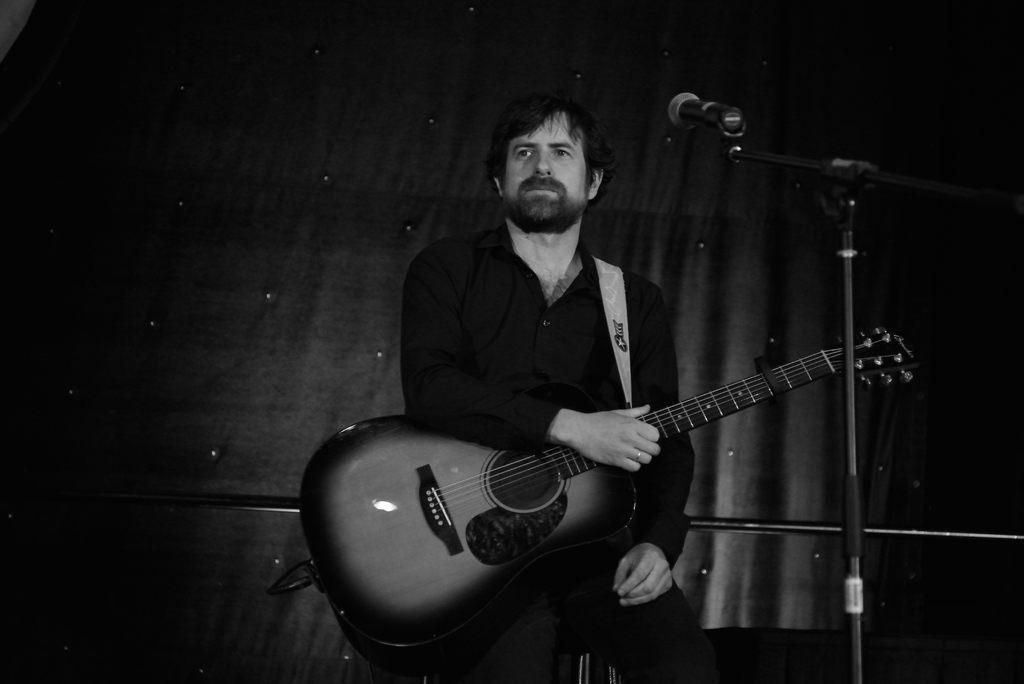Please provide a concise description of this image. In this picture we can see a man holding a guitar in front of microphone, in the background we can see curtains. 